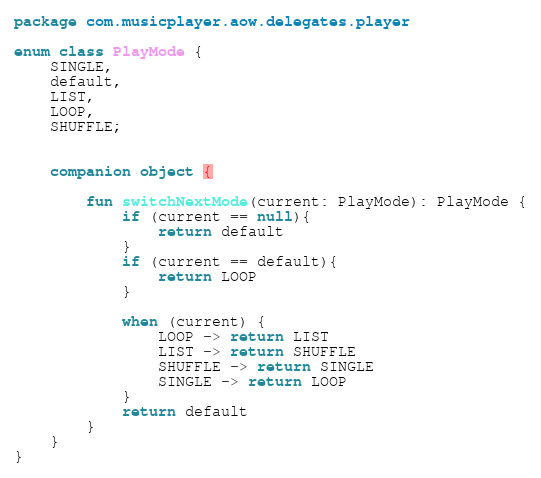Convert code to text. <code><loc_0><loc_0><loc_500><loc_500><_Kotlin_>package com.musicplayer.aow.delegates.player

enum class PlayMode {
    SINGLE,
    default,
    LIST,
    LOOP,
    SHUFFLE;


    companion object {

        fun switchNextMode(current: PlayMode): PlayMode {
            if (current == null){
                return default
            }
            if (current == default){
                return LOOP
            }

            when (current) {
                LOOP -> return LIST
                LIST -> return SHUFFLE
                SHUFFLE -> return SINGLE
                SINGLE -> return LOOP
            }
            return default
        }
    }
}
</code> 